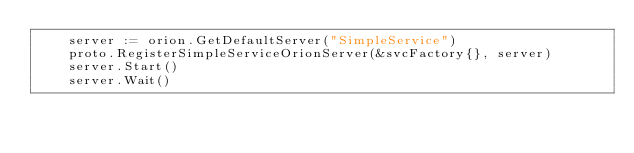<code> <loc_0><loc_0><loc_500><loc_500><_Go_>	server := orion.GetDefaultServer("SimpleService")
	proto.RegisterSimpleServiceOrionServer(&svcFactory{}, server)
	server.Start()
	server.Wait()</code> 